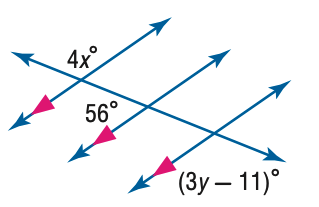Answer the mathemtical geometry problem and directly provide the correct option letter.
Question: Find x in the figure.
Choices: A: 21 B: 26 C: 31 D: 36 C 